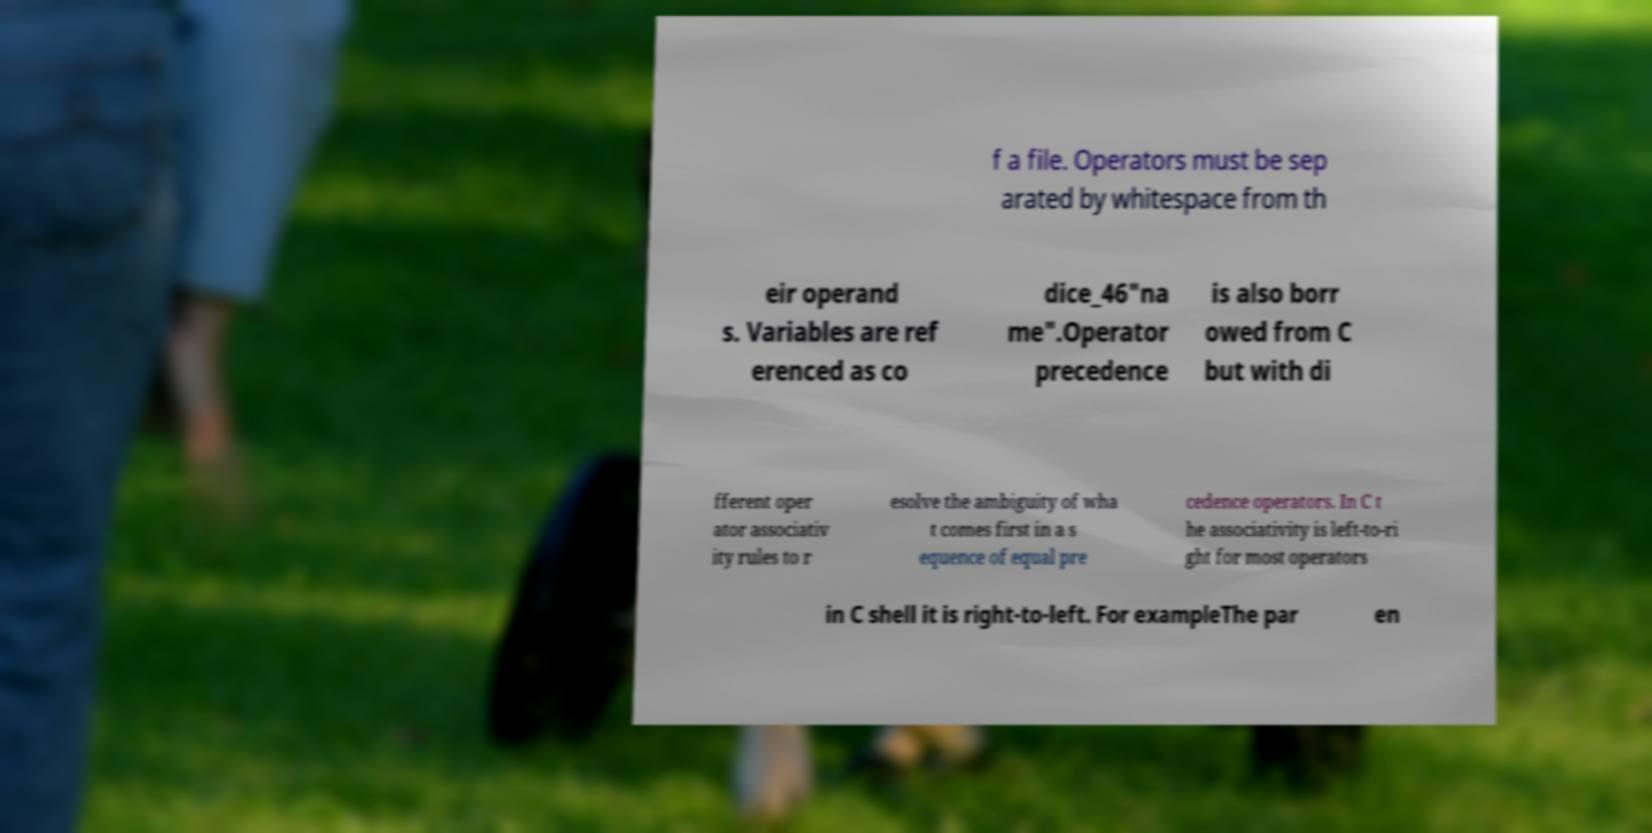Can you read and provide the text displayed in the image?This photo seems to have some interesting text. Can you extract and type it out for me? f a file. Operators must be sep arated by whitespace from th eir operand s. Variables are ref erenced as co dice_46"na me".Operator precedence is also borr owed from C but with di fferent oper ator associativ ity rules to r esolve the ambiguity of wha t comes first in a s equence of equal pre cedence operators. In C t he associativity is left-to-ri ght for most operators in C shell it is right-to-left. For exampleThe par en 